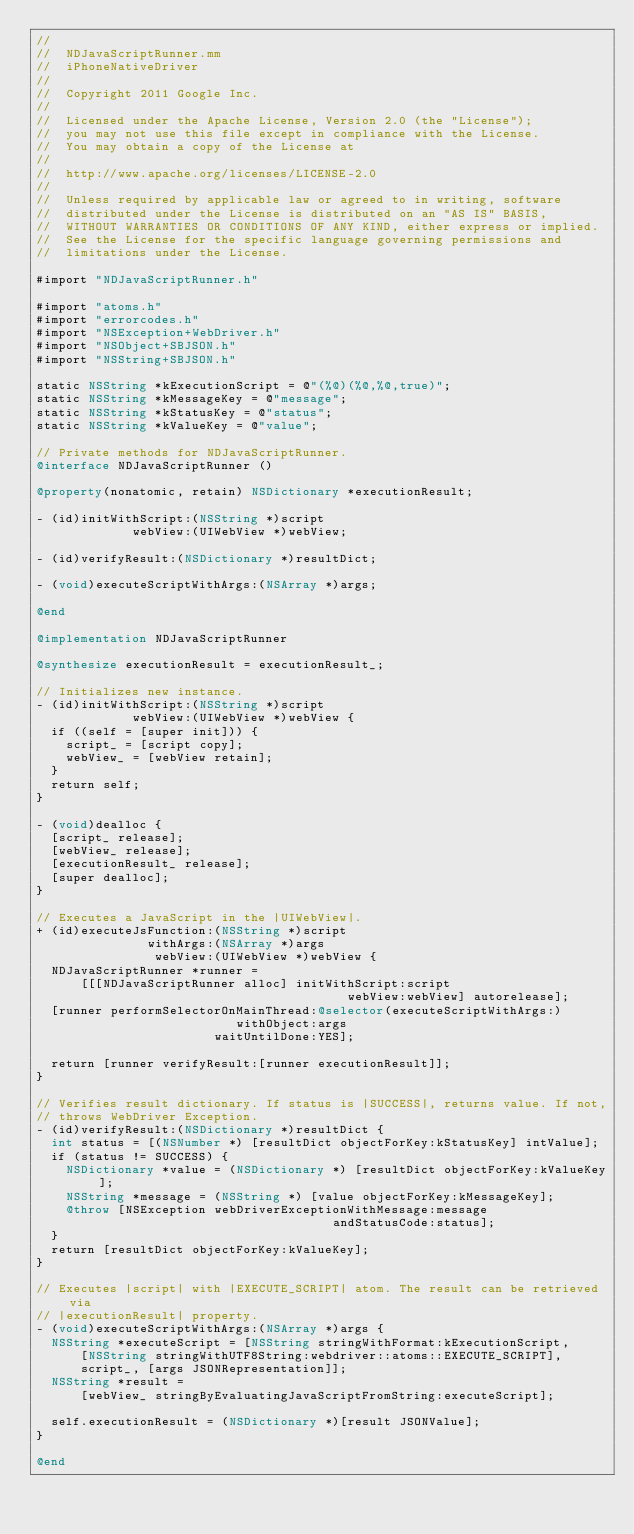Convert code to text. <code><loc_0><loc_0><loc_500><loc_500><_ObjectiveC_>//
//  NDJavaScriptRunner.mm
//  iPhoneNativeDriver
//
//  Copyright 2011 Google Inc.
//
//  Licensed under the Apache License, Version 2.0 (the "License");
//  you may not use this file except in compliance with the License.
//  You may obtain a copy of the License at
//
//  http://www.apache.org/licenses/LICENSE-2.0
//
//  Unless required by applicable law or agreed to in writing, software
//  distributed under the License is distributed on an "AS IS" BASIS,
//  WITHOUT WARRANTIES OR CONDITIONS OF ANY KIND, either express or implied.
//  See the License for the specific language governing permissions and
//  limitations under the License.

#import "NDJavaScriptRunner.h"

#import "atoms.h"
#import "errorcodes.h"
#import "NSException+WebDriver.h"
#import "NSObject+SBJSON.h"
#import "NSString+SBJSON.h"

static NSString *kExecutionScript = @"(%@)(%@,%@,true)";
static NSString *kMessageKey = @"message";
static NSString *kStatusKey = @"status";
static NSString *kValueKey = @"value";

// Private methods for NDJavaScriptRunner.
@interface NDJavaScriptRunner ()

@property(nonatomic, retain) NSDictionary *executionResult;

- (id)initWithScript:(NSString *)script
             webView:(UIWebView *)webView;

- (id)verifyResult:(NSDictionary *)resultDict;

- (void)executeScriptWithArgs:(NSArray *)args;

@end

@implementation NDJavaScriptRunner

@synthesize executionResult = executionResult_;

// Initializes new instance.
- (id)initWithScript:(NSString *)script
             webView:(UIWebView *)webView {
  if ((self = [super init])) {
    script_ = [script copy];
    webView_ = [webView retain];
  }
  return self;
}

- (void)dealloc {
  [script_ release];
  [webView_ release];
  [executionResult_ release];
  [super dealloc];
}

// Executes a JavaScript in the |UIWebView|.
+ (id)executeJsFunction:(NSString *)script
               withArgs:(NSArray *)args
                webView:(UIWebView *)webView {
  NDJavaScriptRunner *runner =
      [[[NDJavaScriptRunner alloc] initWithScript:script
                                          webView:webView] autorelease];
  [runner performSelectorOnMainThread:@selector(executeScriptWithArgs:)
                           withObject:args
                        waitUntilDone:YES];

  return [runner verifyResult:[runner executionResult]];
}

// Verifies result dictionary. If status is |SUCCESS|, returns value. If not,
// throws WebDriver Exception.
- (id)verifyResult:(NSDictionary *)resultDict {
  int status = [(NSNumber *) [resultDict objectForKey:kStatusKey] intValue];
  if (status != SUCCESS) {
    NSDictionary *value = (NSDictionary *) [resultDict objectForKey:kValueKey];
    NSString *message = (NSString *) [value objectForKey:kMessageKey];
    @throw [NSException webDriverExceptionWithMessage:message
                                        andStatusCode:status];
  }
  return [resultDict objectForKey:kValueKey];
}

// Executes |script| with |EXECUTE_SCRIPT| atom. The result can be retrieved via
// |executionResult| property.
- (void)executeScriptWithArgs:(NSArray *)args {
  NSString *executeScript = [NSString stringWithFormat:kExecutionScript,
      [NSString stringWithUTF8String:webdriver::atoms::EXECUTE_SCRIPT],
      script_, [args JSONRepresentation]];
  NSString *result =
      [webView_ stringByEvaluatingJavaScriptFromString:executeScript];

  self.executionResult = (NSDictionary *)[result JSONValue];
}

@end
</code> 